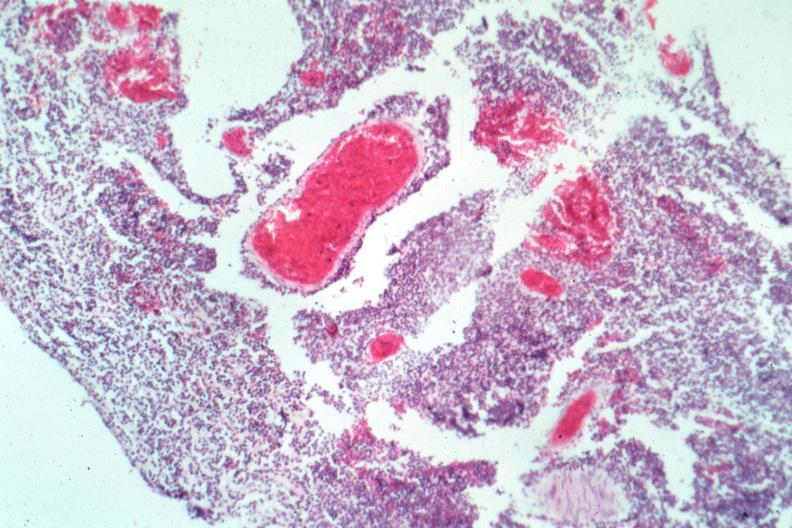s brain present?
Answer the question using a single word or phrase. Yes 